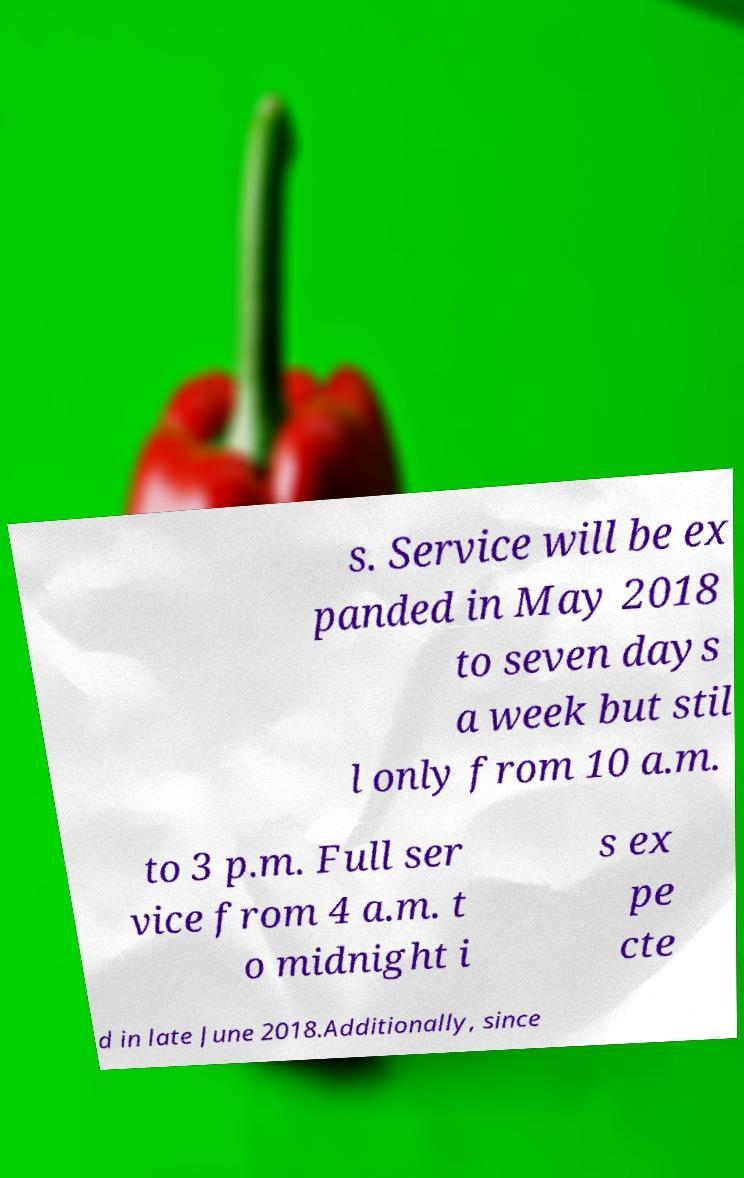Could you extract and type out the text from this image? s. Service will be ex panded in May 2018 to seven days a week but stil l only from 10 a.m. to 3 p.m. Full ser vice from 4 a.m. t o midnight i s ex pe cte d in late June 2018.Additionally, since 